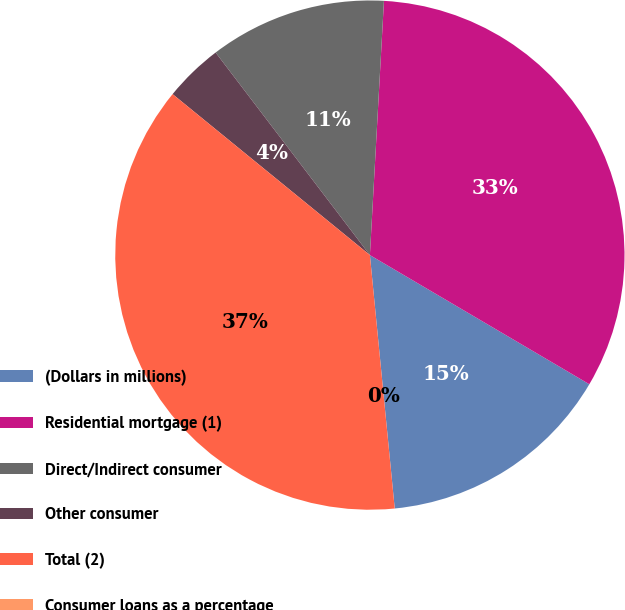Convert chart to OTSL. <chart><loc_0><loc_0><loc_500><loc_500><pie_chart><fcel>(Dollars in millions)<fcel>Residential mortgage (1)<fcel>Direct/Indirect consumer<fcel>Other consumer<fcel>Total (2)<fcel>Consumer loans as a percentage<nl><fcel>14.98%<fcel>32.59%<fcel>11.24%<fcel>3.75%<fcel>37.45%<fcel>0.0%<nl></chart> 